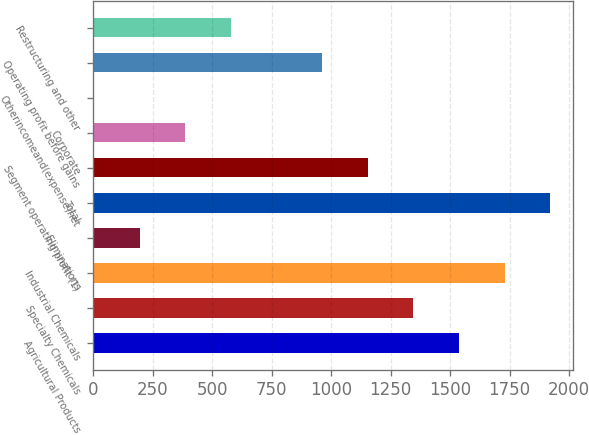Convert chart. <chart><loc_0><loc_0><loc_500><loc_500><bar_chart><fcel>Agricultural Products<fcel>Specialty Chemicals<fcel>Industrial Chemicals<fcel>Eliminations<fcel>Total<fcel>Segment operating profit (1)<fcel>Corporate<fcel>Otherincomeand(expense)net<fcel>Operating profit before gains<fcel>Restructuring and other<nl><fcel>1537.9<fcel>1346.15<fcel>1729.65<fcel>195.65<fcel>1921.4<fcel>1154.4<fcel>387.4<fcel>3.9<fcel>962.65<fcel>579.15<nl></chart> 